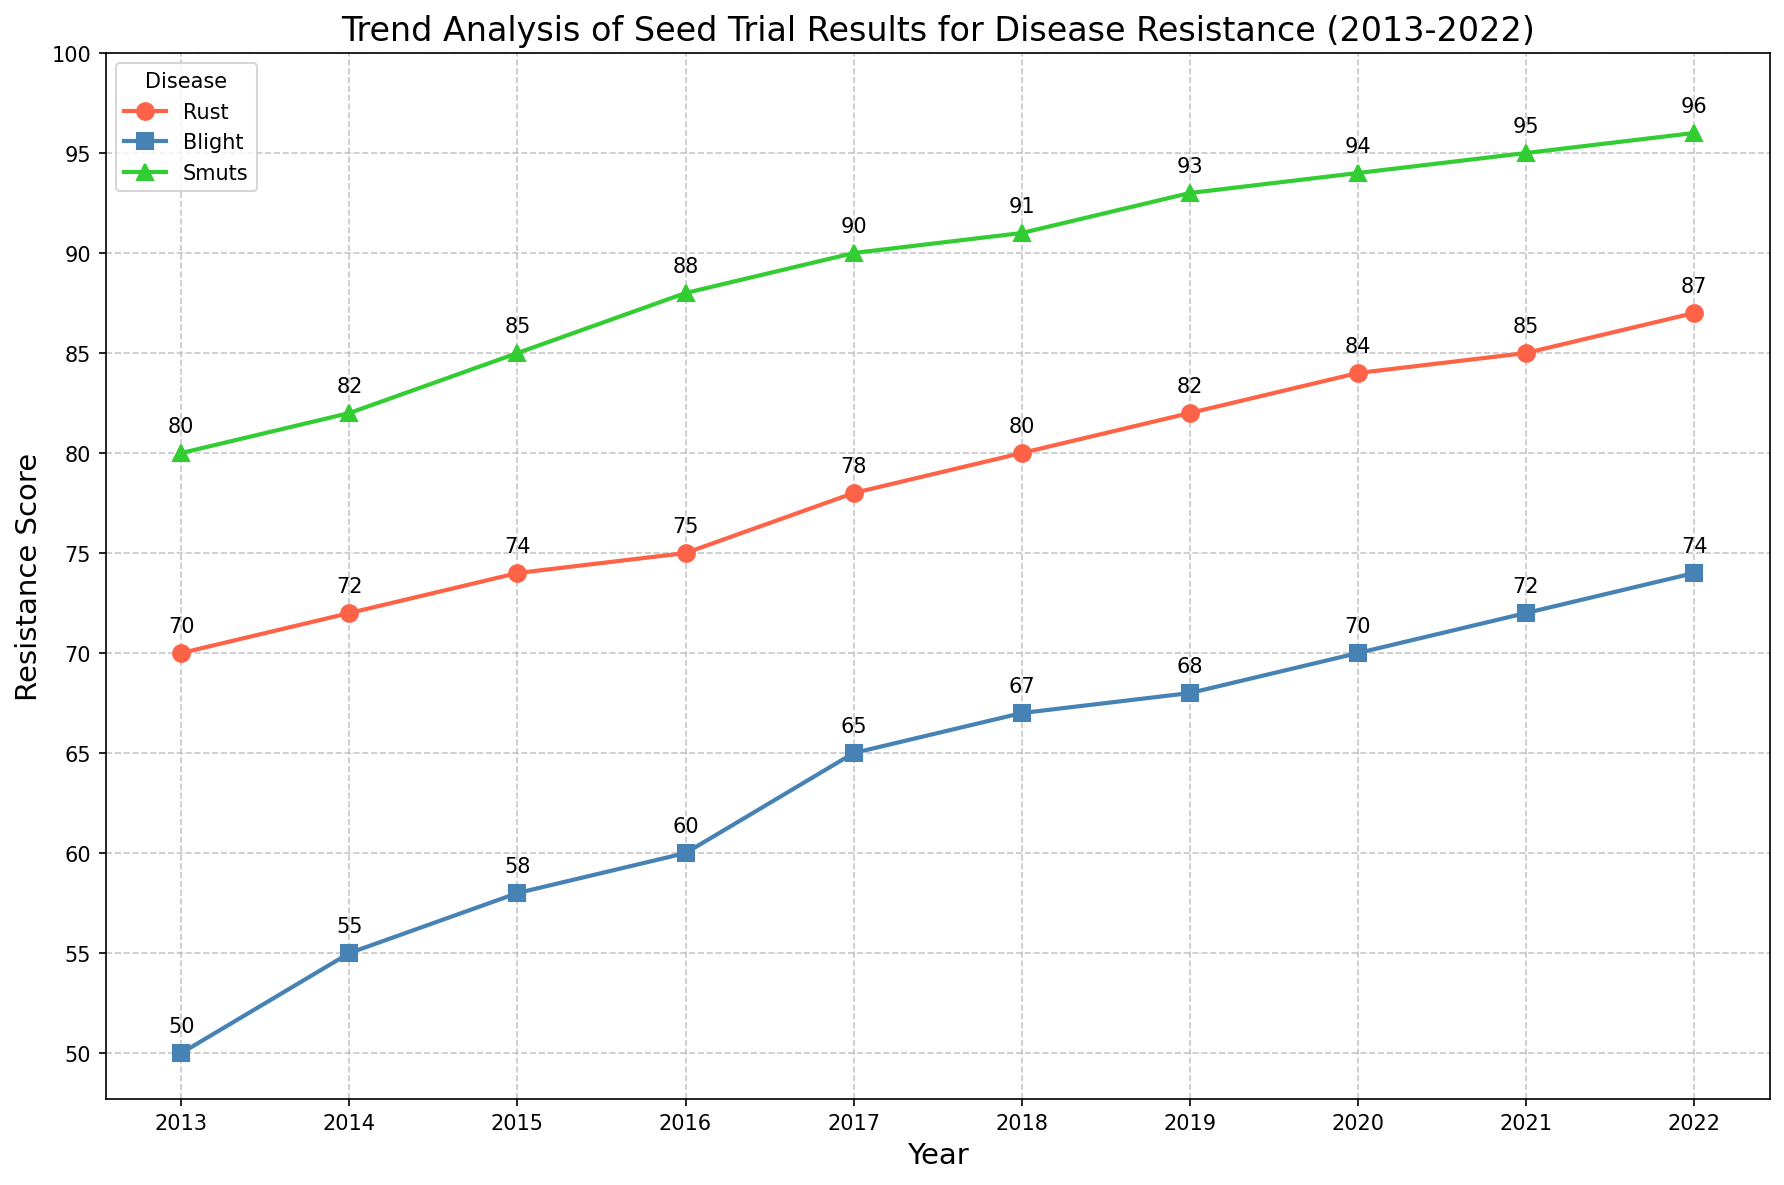Which disease showed the highest resistance score in 2022? To determine the highest resistance score for 2022, check the annotated scores for each disease (Rust, Blight, and Smuts). Rust has 87, Blight has 74, and Smuts has 96. Smuts has the highest resistance score.
Answer: Smuts What is the overall trend for Rust resistance from 2013 to 2022? To identify the trend, observe the annotated scores for Rust across the years. The scores increase sequentially from 70 in 2013 to 87 in 2022, indicating a rising trend in resistance.
Answer: Increasing Which year had the lowest resistance score for Blight, and what was it? Find the lowest resistance score among the annotated values for Blight from 2013 to 2022. The lowest score is 50 in 2013.
Answer: 2013, 50 What is the average resistance score of Smuts over the decade? List the resistance scores for Smuts: 80, 82, 85, 88, 90, 91, 93, 94, 95, 96. The sum is 894. The average is calculated as 894 / 10 = 89.4.
Answer: 89.4 How much did the resistance score for Blight improve from 2013 to 2022? Compare the first and last resistance scores for Blight. The score in 2013 is 50, and in 2022 it is 74. The improvement is 74 - 50 = 24.
Answer: 24 In which year did Rust have a resistance score equal to 75? Look for the year where the annotated score for Rust is 75. The score 75 appears in 2016.
Answer: 2016 What is the difference in resistance scores between Rust and Blight in 2020? Check the scores for Rust and Blight in 2020. Rust has 84 and Blight has 70. The difference is 84 - 70 = 14.
Answer: 14 Which disease has the most stable (least variable) resistance score trend over the decade? Check the variability by inspecting the year-over-year changes in the resistance scores. Blight shows the smallest changes in scores compared to Rust and Smuts, indicating a more stable trend.
Answer: Blight Which disease has its highest resistance score in 2019? Compare the 2019 score for Rust (82), Blight (68), and Smuts (93). Smuts has the highest score in 2019.
Answer: Smuts 